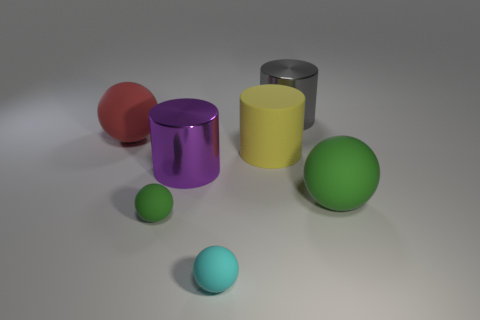Are there any red objects that have the same shape as the large purple metal object?
Make the answer very short. No. Are there the same number of big spheres that are behind the yellow matte object and tiny objects behind the large green sphere?
Provide a succinct answer. No. Does the object to the left of the tiny green sphere have the same shape as the cyan thing?
Offer a terse response. Yes. Is the big yellow matte object the same shape as the tiny cyan object?
Offer a terse response. No. How many shiny objects are either large yellow cylinders or green objects?
Give a very brief answer. 0. Does the yellow rubber cylinder have the same size as the cyan rubber sphere?
Offer a very short reply. No. What number of objects are either tiny yellow metallic blocks or metallic cylinders that are on the left side of the yellow rubber cylinder?
Keep it short and to the point. 1. There is a red object that is the same size as the gray shiny thing; what is its material?
Provide a succinct answer. Rubber. What is the material of the large cylinder that is in front of the large gray metal cylinder and on the right side of the small cyan object?
Keep it short and to the point. Rubber. There is a green matte thing right of the gray shiny cylinder; is there a shiny object on the right side of it?
Offer a very short reply. No. 